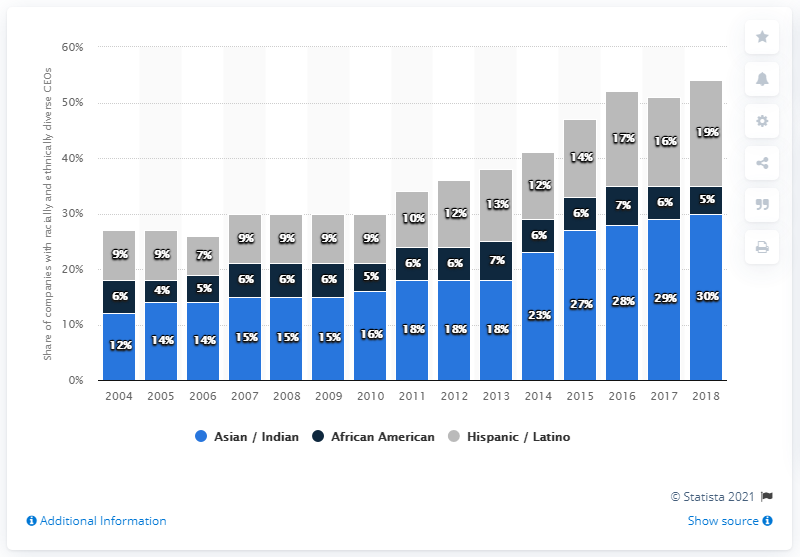Mention a couple of crucial points in this snapshot. In 2018, only 30% of CEOs were African American. In 2018, approximately 30% of CEO positions were held by Asians and Indians. 